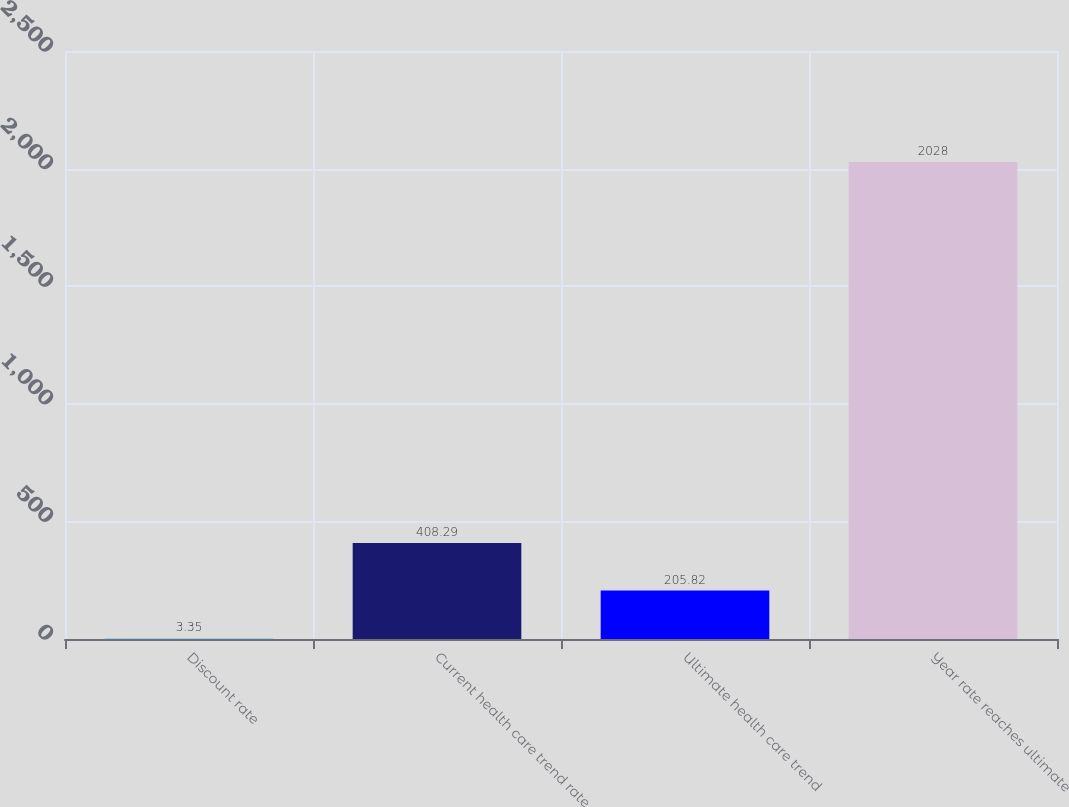Convert chart to OTSL. <chart><loc_0><loc_0><loc_500><loc_500><bar_chart><fcel>Discount rate<fcel>Current health care trend rate<fcel>Ultimate health care trend<fcel>Year rate reaches ultimate<nl><fcel>3.35<fcel>408.29<fcel>205.82<fcel>2028<nl></chart> 